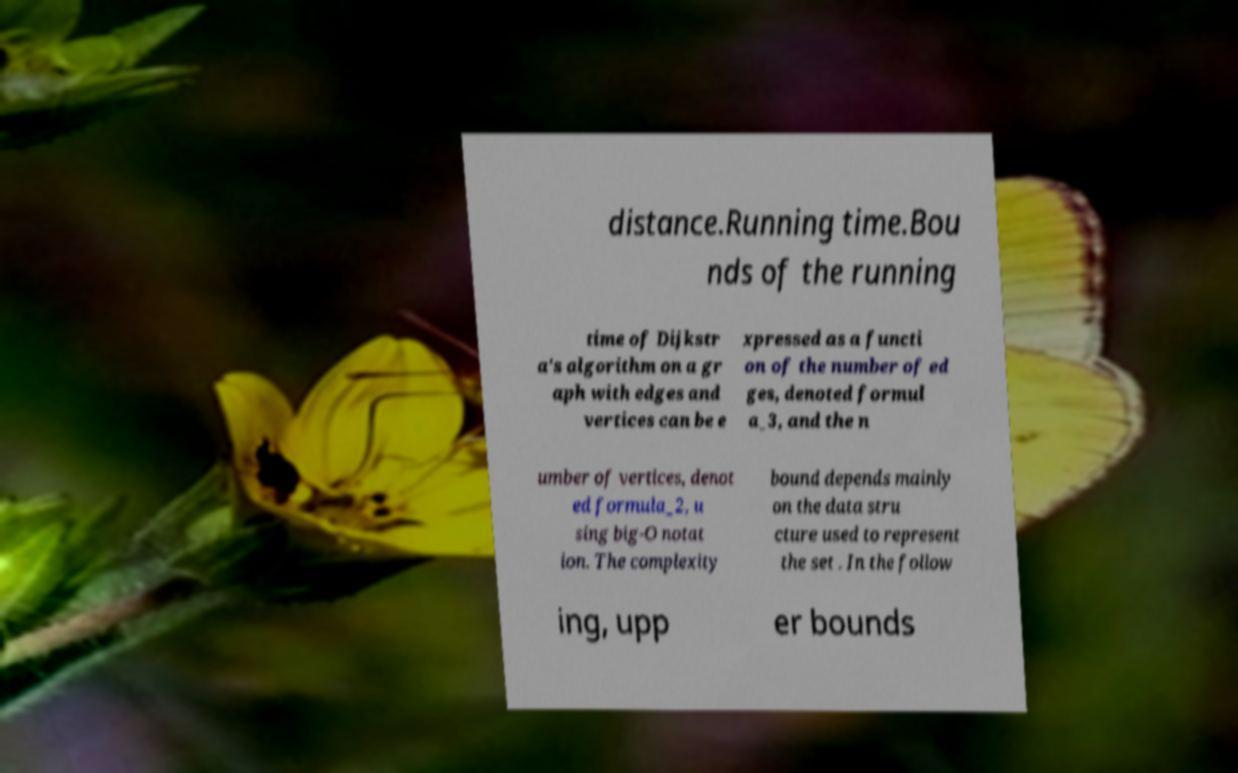Could you assist in decoding the text presented in this image and type it out clearly? distance.Running time.Bou nds of the running time of Dijkstr a's algorithm on a gr aph with edges and vertices can be e xpressed as a functi on of the number of ed ges, denoted formul a_3, and the n umber of vertices, denot ed formula_2, u sing big-O notat ion. The complexity bound depends mainly on the data stru cture used to represent the set . In the follow ing, upp er bounds 